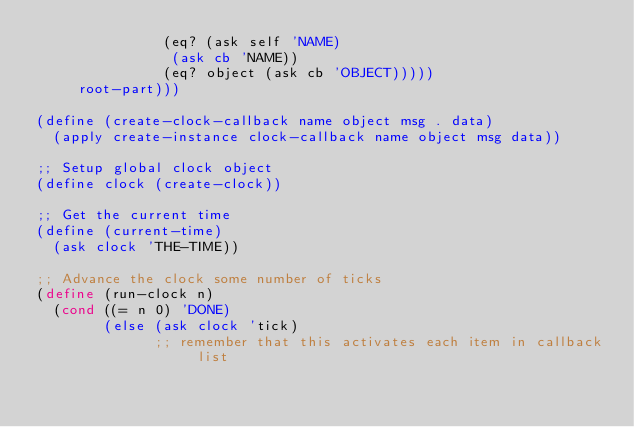Convert code to text. <code><loc_0><loc_0><loc_500><loc_500><_Scheme_>		       (eq? (ask self 'NAME)
			    (ask cb 'NAME))
		       (eq? object (ask cb 'OBJECT)))))
     root-part)))

(define (create-clock-callback name object msg . data)
  (apply create-instance clock-callback name object msg data))

;; Setup global clock object
(define clock (create-clock))

;; Get the current time
(define (current-time)
  (ask clock 'THE-TIME))

;; Advance the clock some number of ticks
(define (run-clock n)
  (cond ((= n 0) 'DONE)
        (else (ask clock 'tick)
              ;; remember that this activates each item in callback list</code> 